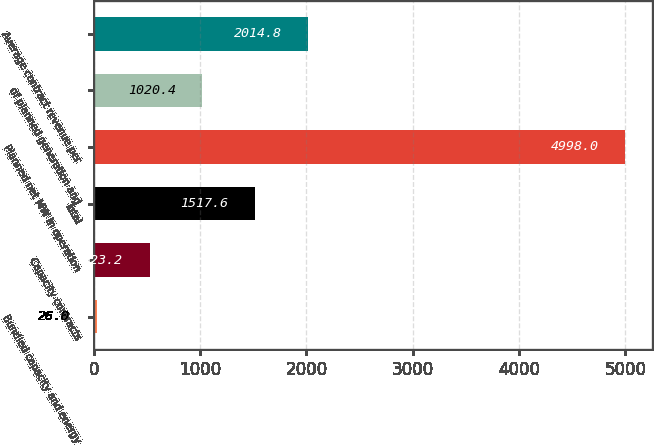Convert chart to OTSL. <chart><loc_0><loc_0><loc_500><loc_500><bar_chart><fcel>Bundled capacity and energy<fcel>Capacity contracts<fcel>Total<fcel>Planned net MW in operation<fcel>of planned generation and<fcel>Average contract revenue per<nl><fcel>26<fcel>523.2<fcel>1517.6<fcel>4998<fcel>1020.4<fcel>2014.8<nl></chart> 